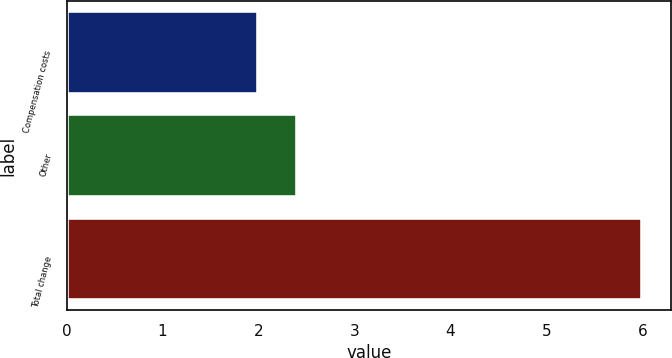Convert chart to OTSL. <chart><loc_0><loc_0><loc_500><loc_500><bar_chart><fcel>Compensation costs<fcel>Other<fcel>Total change<nl><fcel>2<fcel>2.4<fcel>6<nl></chart> 